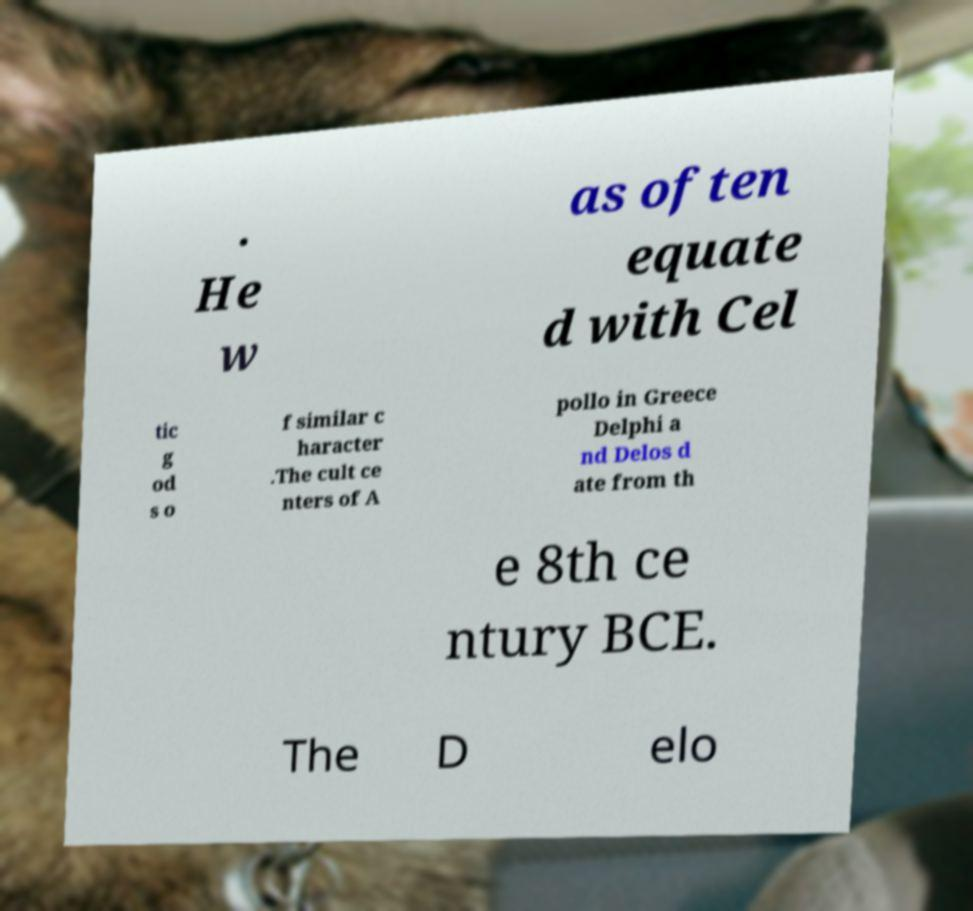I need the written content from this picture converted into text. Can you do that? . He w as often equate d with Cel tic g od s o f similar c haracter .The cult ce nters of A pollo in Greece Delphi a nd Delos d ate from th e 8th ce ntury BCE. The D elo 